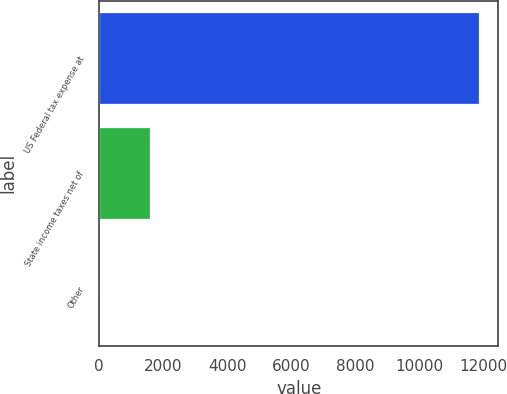<chart> <loc_0><loc_0><loc_500><loc_500><bar_chart><fcel>US Federal tax expense at<fcel>State income taxes net of<fcel>Other<nl><fcel>11878<fcel>1603<fcel>4<nl></chart> 